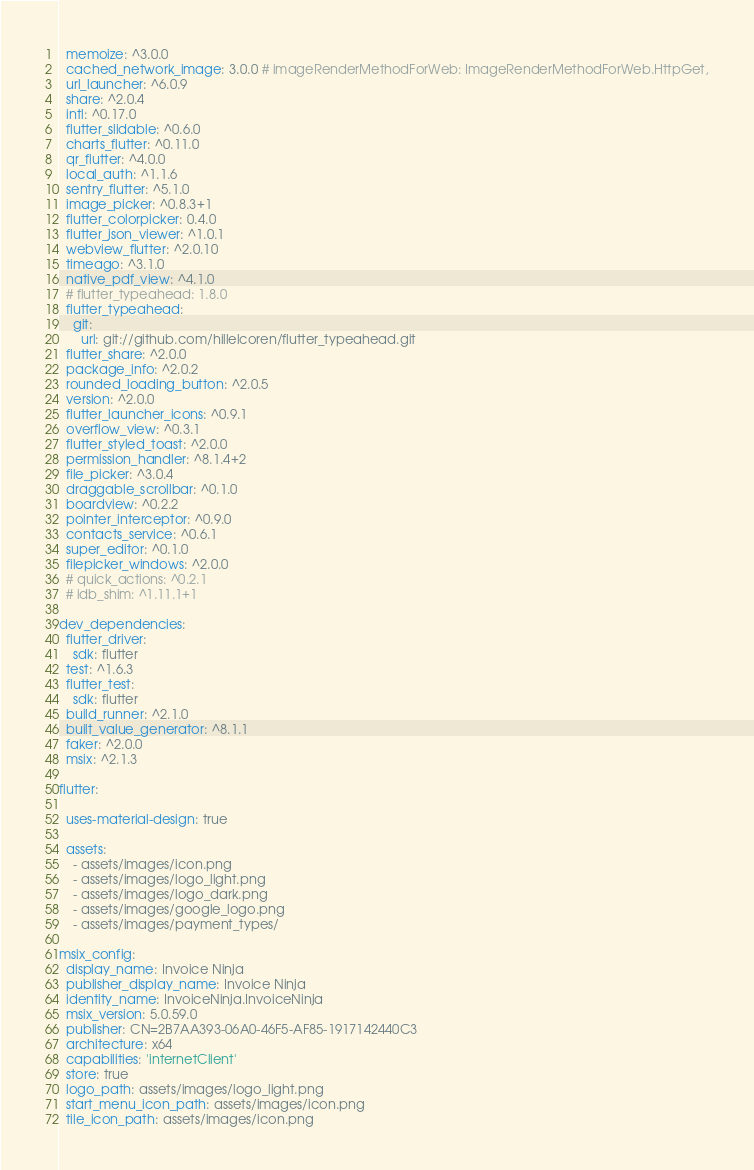Convert code to text. <code><loc_0><loc_0><loc_500><loc_500><_YAML_>  memoize: ^3.0.0
  cached_network_image: 3.0.0 # imageRenderMethodForWeb: ImageRenderMethodForWeb.HttpGet,
  url_launcher: ^6.0.9
  share: ^2.0.4
  intl: ^0.17.0
  flutter_slidable: ^0.6.0
  charts_flutter: ^0.11.0
  qr_flutter: ^4.0.0
  local_auth: ^1.1.6
  sentry_flutter: ^5.1.0
  image_picker: ^0.8.3+1
  flutter_colorpicker: 0.4.0
  flutter_json_viewer: ^1.0.1
  webview_flutter: ^2.0.10
  timeago: ^3.1.0
  native_pdf_view: ^4.1.0
  # flutter_typeahead: 1.8.0
  flutter_typeahead:
    git:
      url: git://github.com/hillelcoren/flutter_typeahead.git
  flutter_share: ^2.0.0
  package_info: ^2.0.2
  rounded_loading_button: ^2.0.5
  version: ^2.0.0
  flutter_launcher_icons: ^0.9.1
  overflow_view: ^0.3.1
  flutter_styled_toast: ^2.0.0
  permission_handler: ^8.1.4+2
  file_picker: ^3.0.4
  draggable_scrollbar: ^0.1.0
  boardview: ^0.2.2
  pointer_interceptor: ^0.9.0
  contacts_service: ^0.6.1
  super_editor: ^0.1.0
  filepicker_windows: ^2.0.0
  # quick_actions: ^0.2.1
  # idb_shim: ^1.11.1+1

dev_dependencies:
  flutter_driver:
    sdk: flutter
  test: ^1.6.3
  flutter_test:
    sdk: flutter
  build_runner: ^2.1.0
  built_value_generator: ^8.1.1
  faker: ^2.0.0
  msix: ^2.1.3

flutter:

  uses-material-design: true

  assets:
    - assets/images/icon.png
    - assets/images/logo_light.png
    - assets/images/logo_dark.png
    - assets/images/google_logo.png
    - assets/images/payment_types/

msix_config:
  display_name: Invoice Ninja
  publisher_display_name: Invoice Ninja
  identity_name: InvoiceNinja.InvoiceNinja
  msix_version: 5.0.59.0
  publisher: CN=2B7AA393-06A0-46F5-AF85-1917142440C3
  architecture: x64
  capabilities: 'internetClient'
  store: true
  logo_path: assets/images/logo_light.png
  start_menu_icon_path: assets/images/icon.png
  tile_icon_path: assets/images/icon.png</code> 